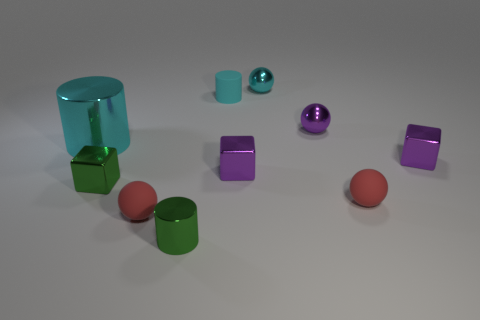How many other objects are the same material as the large cylinder?
Offer a very short reply. 6. What size is the green block?
Your answer should be compact. Small. What number of other things are there of the same color as the tiny rubber cylinder?
Make the answer very short. 2. What is the color of the metal thing that is behind the big cyan metallic thing and in front of the small cyan metallic thing?
Provide a short and direct response. Purple. What number of metallic spheres are there?
Keep it short and to the point. 2. Are the small green cube and the big object made of the same material?
Provide a succinct answer. Yes. There is a red rubber thing on the left side of the matte object behind the tiny purple metallic cube that is to the right of the small purple ball; what shape is it?
Your response must be concise. Sphere. Is the material of the tiny cylinder that is behind the big cyan metal cylinder the same as the cyan object that is left of the small cyan matte cylinder?
Your answer should be very brief. No. What is the small purple sphere made of?
Make the answer very short. Metal. What number of other objects have the same shape as the large cyan thing?
Offer a terse response. 2. 